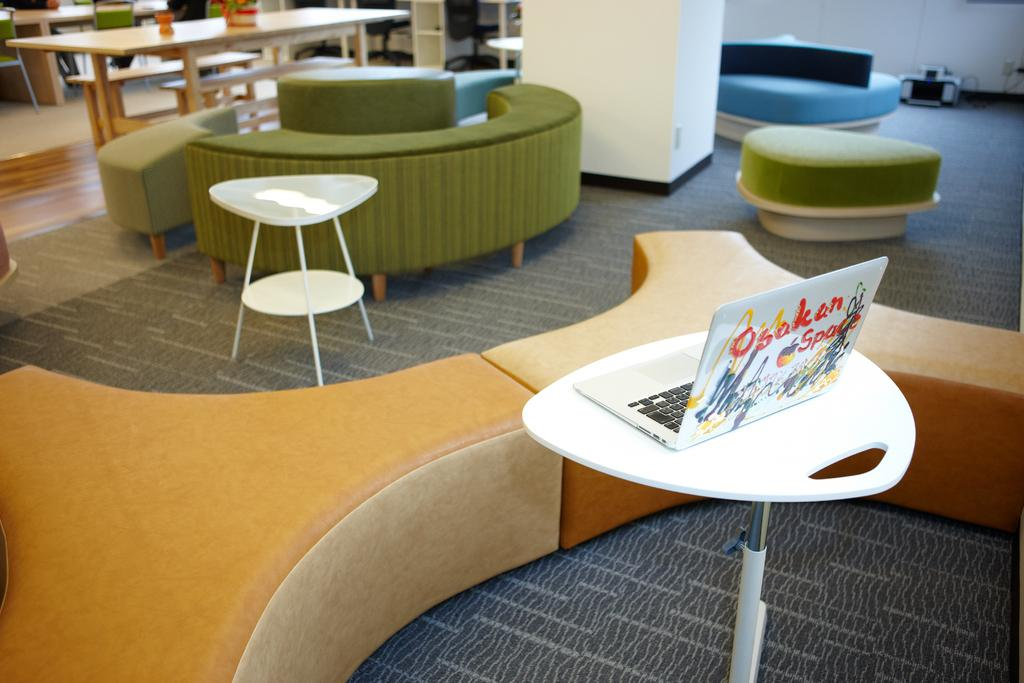What is the main object on the stand in the image? There is a laptop on a stand in the image. What type of furniture can be seen in the background of the image? There is yellow and green color furniture in the background of the image. What is the purpose of the stools in the image? The stools in the background of the image might be used for sitting. What can be found on the table in the image? There are objects on a table in the image. What type of glue is being used to attach the blade to the market in the image? There is no glue, blade, or market present in the image. 